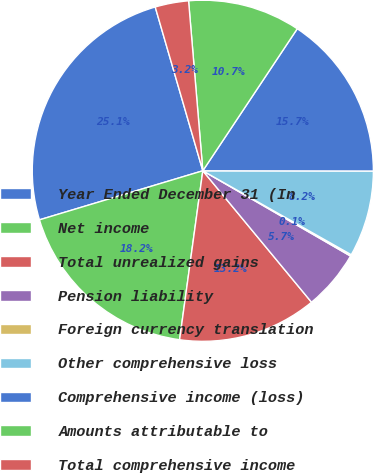Convert chart to OTSL. <chart><loc_0><loc_0><loc_500><loc_500><pie_chart><fcel>Year Ended December 31 (In<fcel>Net income<fcel>Total unrealized gains<fcel>Pension liability<fcel>Foreign currency translation<fcel>Other comprehensive loss<fcel>Comprehensive income (loss)<fcel>Amounts attributable to<fcel>Total comprehensive income<nl><fcel>25.14%<fcel>18.18%<fcel>13.17%<fcel>5.67%<fcel>0.14%<fcel>8.17%<fcel>15.68%<fcel>10.67%<fcel>3.17%<nl></chart> 